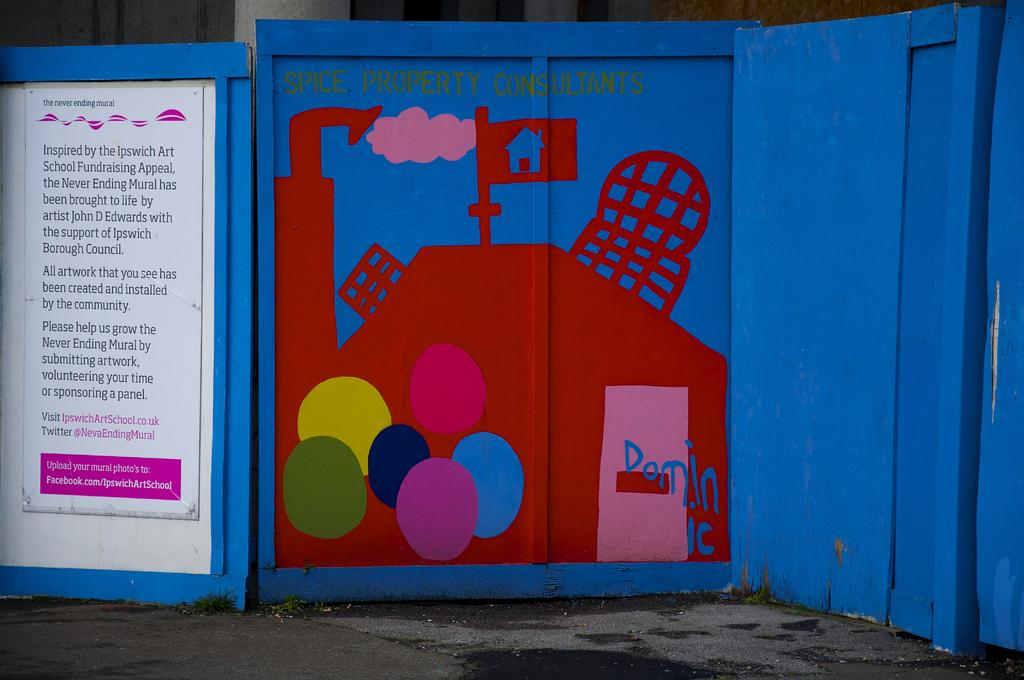<image>
Provide a brief description of the given image. a blue and red door that says spice property consultants on it 